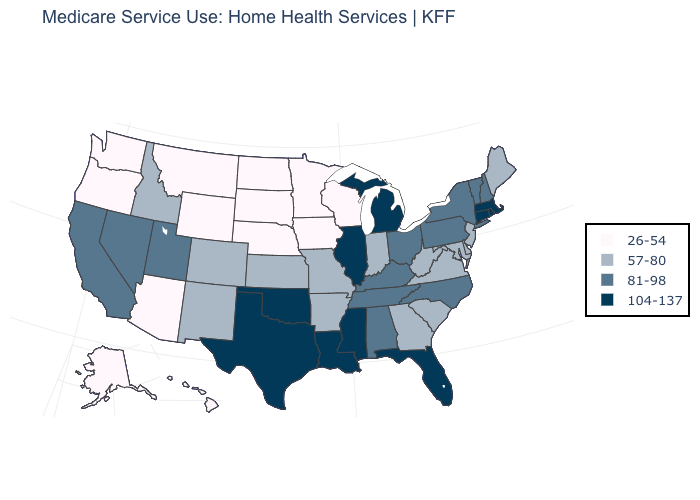Name the states that have a value in the range 26-54?
Short answer required. Alaska, Arizona, Hawaii, Iowa, Minnesota, Montana, Nebraska, North Dakota, Oregon, South Dakota, Washington, Wisconsin, Wyoming. What is the value of Idaho?
Keep it brief. 57-80. Name the states that have a value in the range 57-80?
Be succinct. Arkansas, Colorado, Delaware, Georgia, Idaho, Indiana, Kansas, Maine, Maryland, Missouri, New Jersey, New Mexico, South Carolina, Virginia, West Virginia. What is the lowest value in states that border Colorado?
Short answer required. 26-54. What is the highest value in the Northeast ?
Give a very brief answer. 104-137. Name the states that have a value in the range 104-137?
Answer briefly. Connecticut, Florida, Illinois, Louisiana, Massachusetts, Michigan, Mississippi, Oklahoma, Rhode Island, Texas. Does New Mexico have the highest value in the USA?
Concise answer only. No. Name the states that have a value in the range 81-98?
Write a very short answer. Alabama, California, Kentucky, Nevada, New Hampshire, New York, North Carolina, Ohio, Pennsylvania, Tennessee, Utah, Vermont. What is the lowest value in states that border Oregon?
Answer briefly. 26-54. Which states hav the highest value in the West?
Be succinct. California, Nevada, Utah. Name the states that have a value in the range 81-98?
Answer briefly. Alabama, California, Kentucky, Nevada, New Hampshire, New York, North Carolina, Ohio, Pennsylvania, Tennessee, Utah, Vermont. Name the states that have a value in the range 57-80?
Give a very brief answer. Arkansas, Colorado, Delaware, Georgia, Idaho, Indiana, Kansas, Maine, Maryland, Missouri, New Jersey, New Mexico, South Carolina, Virginia, West Virginia. Name the states that have a value in the range 81-98?
Quick response, please. Alabama, California, Kentucky, Nevada, New Hampshire, New York, North Carolina, Ohio, Pennsylvania, Tennessee, Utah, Vermont. Which states have the lowest value in the USA?
Write a very short answer. Alaska, Arizona, Hawaii, Iowa, Minnesota, Montana, Nebraska, North Dakota, Oregon, South Dakota, Washington, Wisconsin, Wyoming. Does Michigan have the highest value in the USA?
Keep it brief. Yes. 